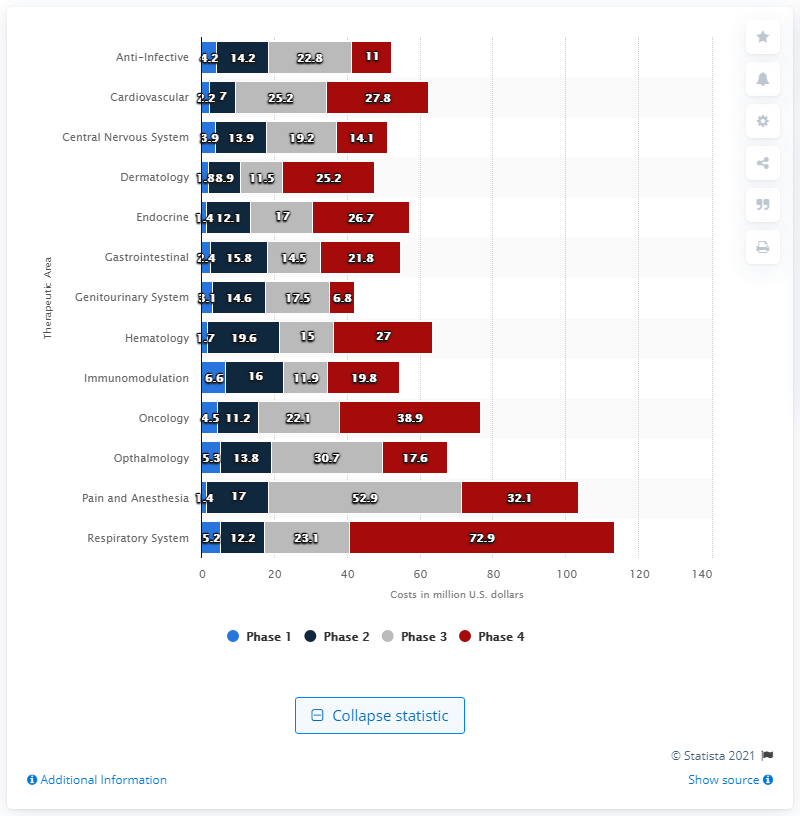Identify some key points in this picture. The total per-study cost of the respiratory system phase IV was $72.9 million. The color red typically indicates a particular phase or condition, specifically Phase 4. The average cost for the respiratory system during the four phases was 28.35. 